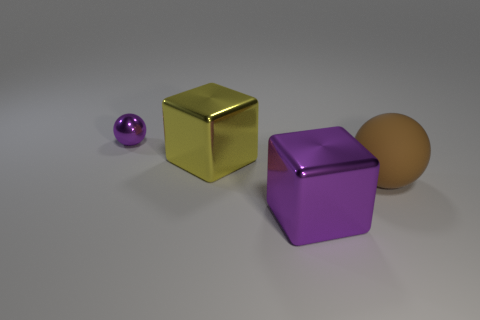There is a block that is the same size as the yellow thing; what color is it?
Provide a short and direct response. Purple. Are there any large matte balls that have the same color as the small metal sphere?
Give a very brief answer. No. Is the number of large purple metallic blocks that are in front of the small thing less than the number of big purple metal cubes that are on the left side of the purple metal block?
Your response must be concise. No. There is a big thing that is both left of the large brown object and in front of the yellow object; what material is it?
Ensure brevity in your answer.  Metal. There is a yellow shiny thing; is its shape the same as the purple thing that is in front of the purple metal ball?
Provide a short and direct response. Yes. How many other objects are the same size as the purple sphere?
Your response must be concise. 0. Are there more purple matte blocks than brown spheres?
Make the answer very short. No. How many big things are both in front of the large matte thing and behind the big purple object?
Offer a terse response. 0. There is a purple metal thing left of the purple thing that is in front of the large block behind the large brown sphere; what is its shape?
Offer a terse response. Sphere. Is there any other thing that is the same shape as the small object?
Offer a terse response. Yes. 